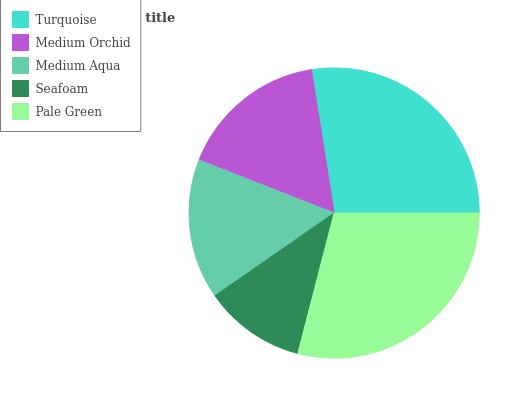Is Seafoam the minimum?
Answer yes or no. Yes. Is Pale Green the maximum?
Answer yes or no. Yes. Is Medium Orchid the minimum?
Answer yes or no. No. Is Medium Orchid the maximum?
Answer yes or no. No. Is Turquoise greater than Medium Orchid?
Answer yes or no. Yes. Is Medium Orchid less than Turquoise?
Answer yes or no. Yes. Is Medium Orchid greater than Turquoise?
Answer yes or no. No. Is Turquoise less than Medium Orchid?
Answer yes or no. No. Is Medium Orchid the high median?
Answer yes or no. Yes. Is Medium Orchid the low median?
Answer yes or no. Yes. Is Turquoise the high median?
Answer yes or no. No. Is Medium Aqua the low median?
Answer yes or no. No. 